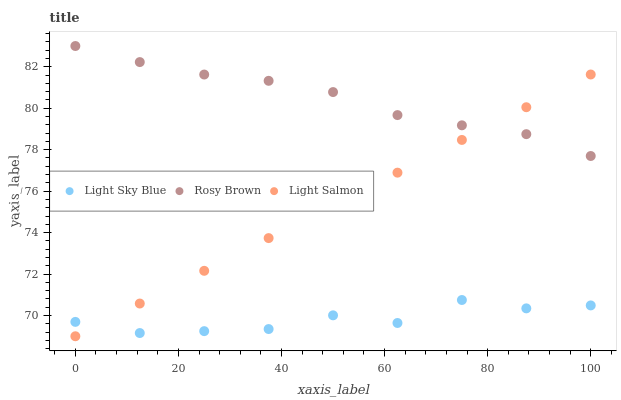Does Light Sky Blue have the minimum area under the curve?
Answer yes or no. Yes. Does Rosy Brown have the maximum area under the curve?
Answer yes or no. Yes. Does Light Salmon have the minimum area under the curve?
Answer yes or no. No. Does Light Salmon have the maximum area under the curve?
Answer yes or no. No. Is Light Salmon the smoothest?
Answer yes or no. Yes. Is Light Sky Blue the roughest?
Answer yes or no. Yes. Is Light Sky Blue the smoothest?
Answer yes or no. No. Is Light Salmon the roughest?
Answer yes or no. No. Does Light Salmon have the lowest value?
Answer yes or no. Yes. Does Light Sky Blue have the lowest value?
Answer yes or no. No. Does Rosy Brown have the highest value?
Answer yes or no. Yes. Does Light Salmon have the highest value?
Answer yes or no. No. Is Light Sky Blue less than Rosy Brown?
Answer yes or no. Yes. Is Rosy Brown greater than Light Sky Blue?
Answer yes or no. Yes. Does Light Salmon intersect Rosy Brown?
Answer yes or no. Yes. Is Light Salmon less than Rosy Brown?
Answer yes or no. No. Is Light Salmon greater than Rosy Brown?
Answer yes or no. No. Does Light Sky Blue intersect Rosy Brown?
Answer yes or no. No. 